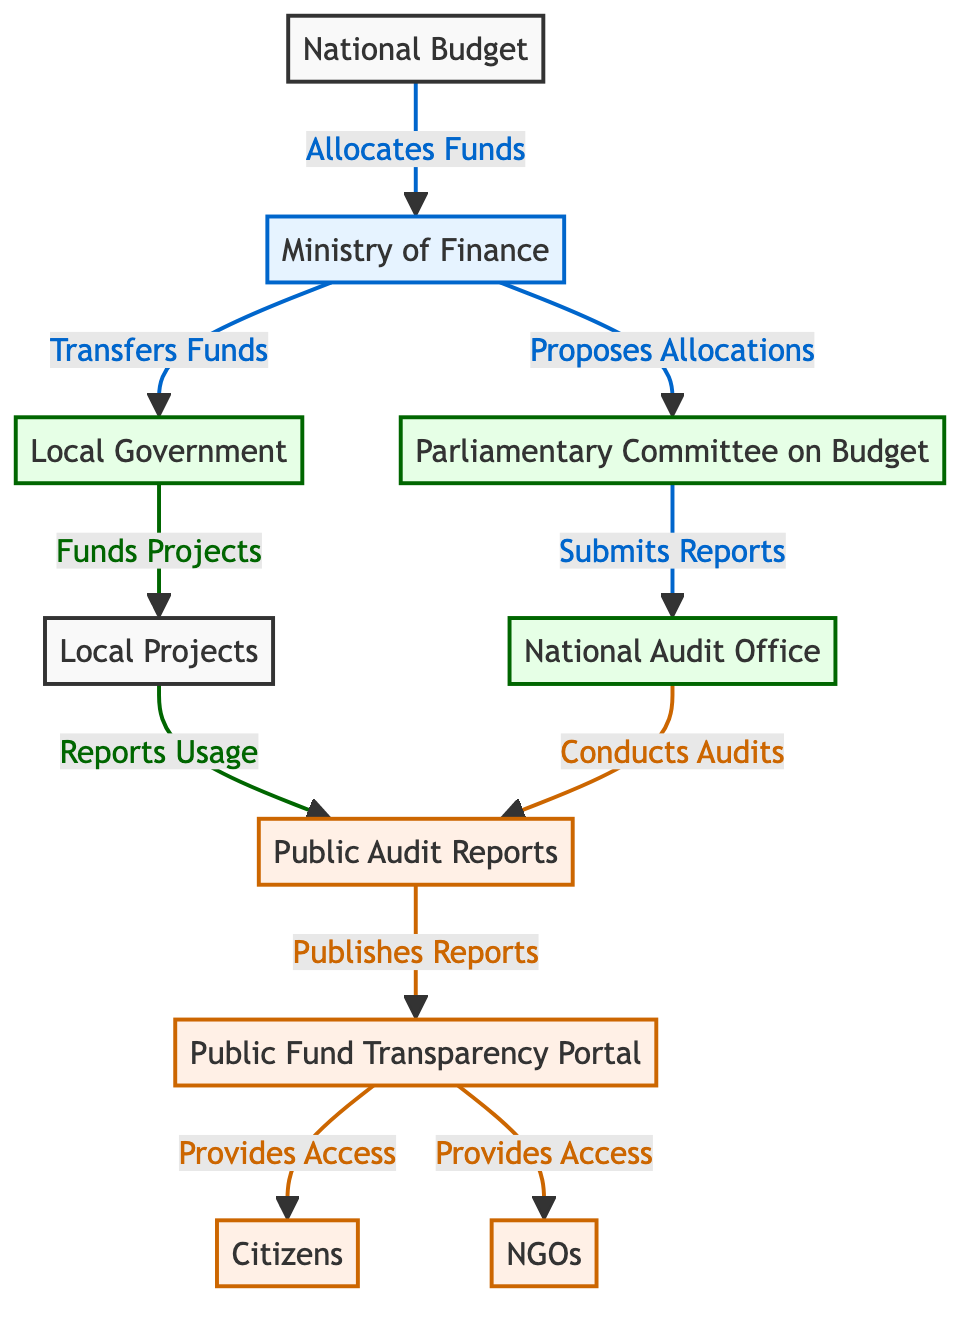What is the first node in the flow? The first node in the flow is the "National Budget," which is shown as the starting point in the directed graph.
Answer: National Budget How many nodes are there in total? By counting the individual nodes listed in the diagram, there are ten nodes in total.
Answer: 10 What is the relationship between the Ministry of Finance and Local Government? The relationship is that the Ministry of Finance "Transfers Funds" to the Local Government, as depicted by the directed edge connecting them.
Answer: Transfers Funds Which entity submits reports to the National Audit Office? The "Parliamentary Committee on Budget" submits reports to the National Audit Office, as indicated by the directed edge connecting these two nodes.
Answer: Parliamentary Committee on Budget What do Public Audit Reports provide access to? Public Audit Reports provide access to both "Citizens" and "NGOs," as shown by the edges leading from Public Audit Reports to these two nodes.
Answer: Citizens, NGOs Which node conducts audits? The node that conducts audits is the "National Audit Office," as per the directed edge indicating this relationship to Public Audit Reports.
Answer: National Audit Office How are Local Projects funded? Local Projects are funded by the "Local Government," which allocates funds to them according to the flow depicted in the diagram.
Answer: Local Government What is the endpoint of the flow? The endpoint of the flow is the "Public Fund Transparency Portal," which is where the final reports are published and accessed.
Answer: Public Fund Transparency Portal Which node receives access from the Public Fund Transparency Portal? The nodes that receive access from the Public Fund Transparency Portal are "Citizens" and "NGOs," as indicated by the two directed edges leading to these nodes.
Answer: Citizens, NGOs How many edges connect to the Parliament Committee on Budget? The Parliamentary Committee on Budget has two incoming edges: one from the Ministry of Finance and one outgoing edge to the National Audit Office, making a total of two edges connected to it.
Answer: 2 